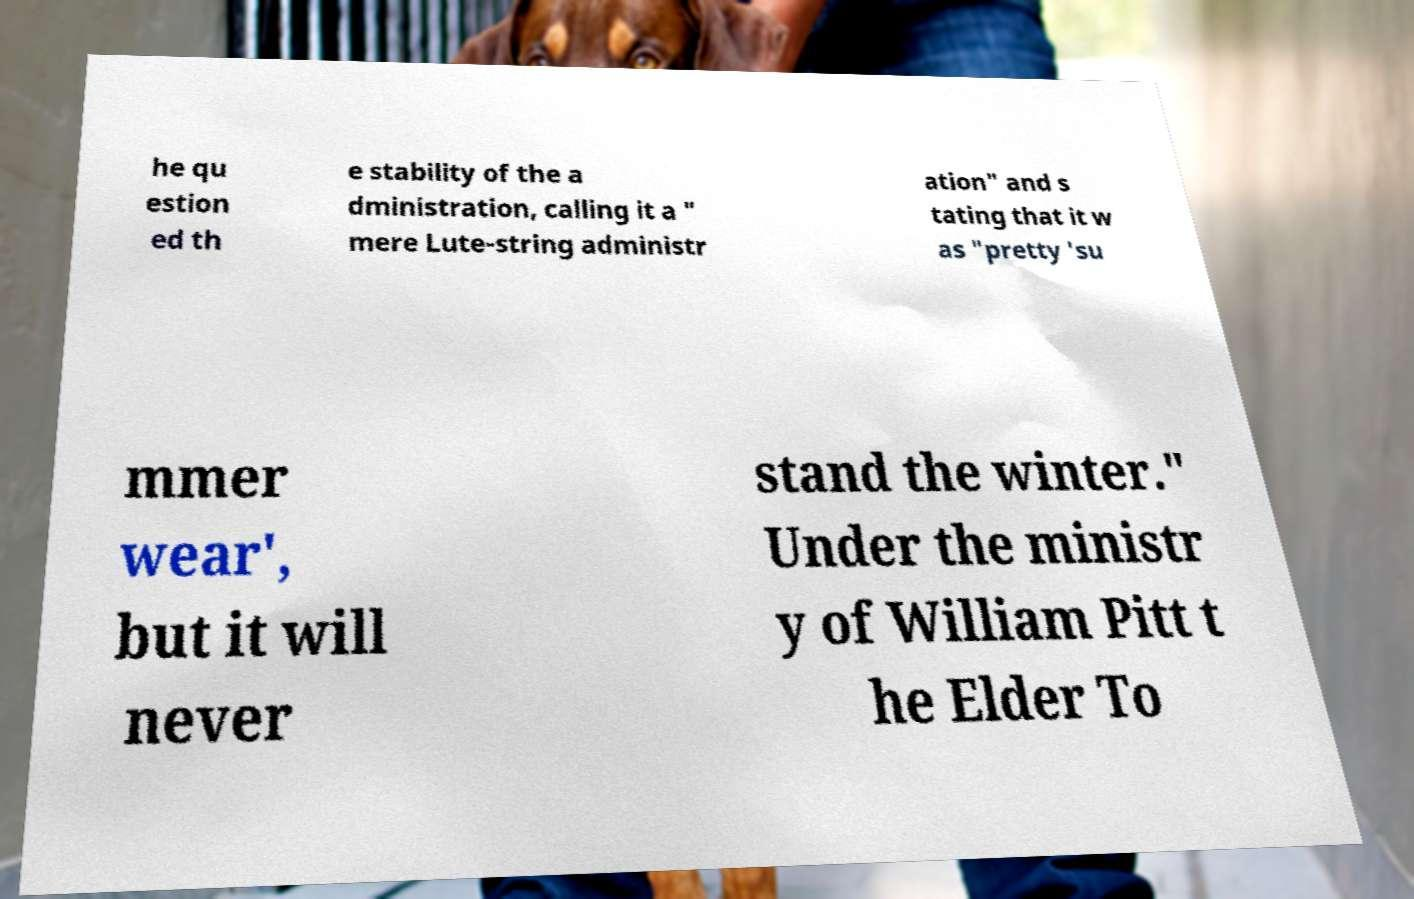There's text embedded in this image that I need extracted. Can you transcribe it verbatim? he qu estion ed th e stability of the a dministration, calling it a " mere Lute-string administr ation" and s tating that it w as "pretty 'su mmer wear', but it will never stand the winter." Under the ministr y of William Pitt t he Elder To 